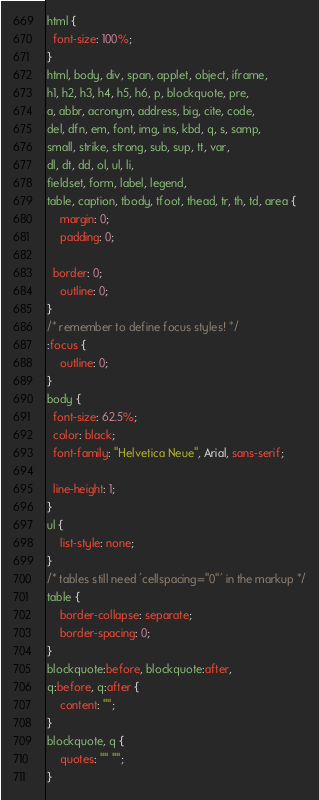Convert code to text. <code><loc_0><loc_0><loc_500><loc_500><_CSS_>html {
  font-size: 100%;
}
html, body, div, span, applet, object, iframe,
h1, h2, h3, h4, h5, h6, p, blockquote, pre,
a, abbr, acronym, address, big, cite, code,
del, dfn, em, font, img, ins, kbd, q, s, samp,
small, strike, strong, sub, sup, tt, var,
dl, dt, dd, ol, ul, li,
fieldset, form, label, legend,
table, caption, tbody, tfoot, thead, tr, th, td, area {
	margin: 0;
	padding: 0;
	
  border: 0;
	outline: 0;
}
/* remember to define focus styles! */
:focus {
	outline: 0;
}
body {	
  font-size: 62.5%;
  color: black;  
  font-family: "Helvetica Neue", Arial, sans-serif;
	
  line-height: 1;
}
ul {
	list-style: none;
}
/* tables still need 'cellspacing="0"' in the markup */
table {
	border-collapse: separate;
	border-spacing: 0;
}
blockquote:before, blockquote:after,
q:before, q:after {
	content: "";
}
blockquote, q {
	quotes: "" "";
}</code> 